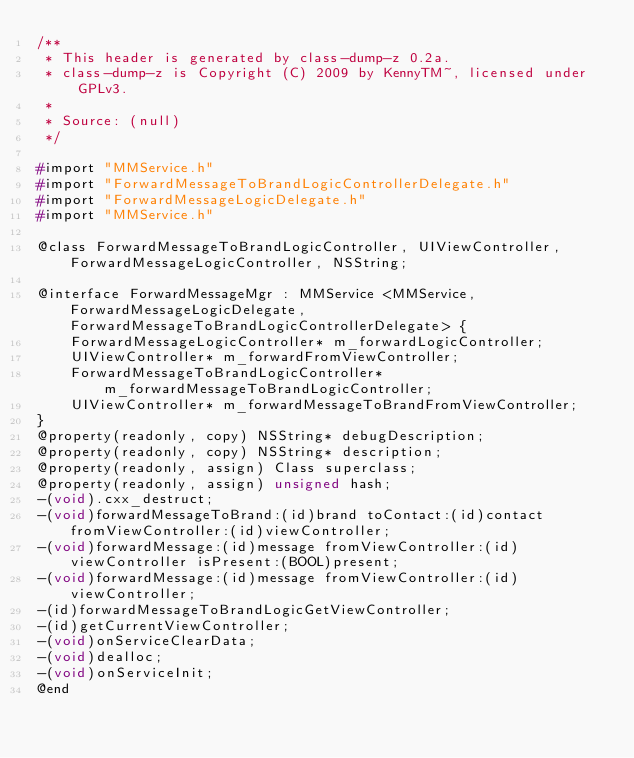Convert code to text. <code><loc_0><loc_0><loc_500><loc_500><_C_>/**
 * This header is generated by class-dump-z 0.2a.
 * class-dump-z is Copyright (C) 2009 by KennyTM~, licensed under GPLv3.
 *
 * Source: (null)
 */

#import "MMService.h"
#import "ForwardMessageToBrandLogicControllerDelegate.h"
#import "ForwardMessageLogicDelegate.h"
#import "MMService.h"

@class ForwardMessageToBrandLogicController, UIViewController, ForwardMessageLogicController, NSString;

@interface ForwardMessageMgr : MMService <MMService, ForwardMessageLogicDelegate, ForwardMessageToBrandLogicControllerDelegate> {
	ForwardMessageLogicController* m_forwardLogicController;
	UIViewController* m_forwardFromViewController;
	ForwardMessageToBrandLogicController* m_forwardMessageToBrandLogicController;
	UIViewController* m_forwardMessageToBrandFromViewController;
}
@property(readonly, copy) NSString* debugDescription;
@property(readonly, copy) NSString* description;
@property(readonly, assign) Class superclass;
@property(readonly, assign) unsigned hash;
-(void).cxx_destruct;
-(void)forwardMessageToBrand:(id)brand toContact:(id)contact fromViewController:(id)viewController;
-(void)forwardMessage:(id)message fromViewController:(id)viewController isPresent:(BOOL)present;
-(void)forwardMessage:(id)message fromViewController:(id)viewController;
-(id)forwardMessageToBrandLogicGetViewController;
-(id)getCurrentViewController;
-(void)onServiceClearData;
-(void)dealloc;
-(void)onServiceInit;
@end

</code> 